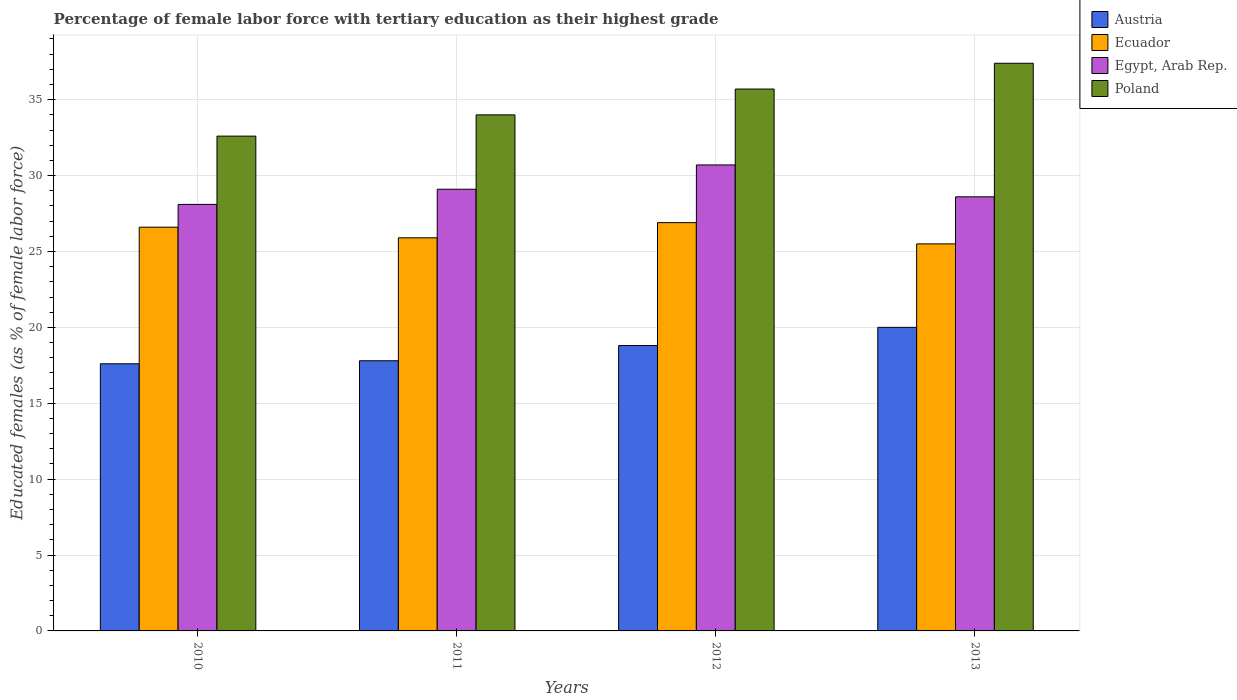How many different coloured bars are there?
Give a very brief answer. 4. Are the number of bars per tick equal to the number of legend labels?
Make the answer very short. Yes. In how many cases, is the number of bars for a given year not equal to the number of legend labels?
Give a very brief answer. 0. What is the percentage of female labor force with tertiary education in Austria in 2013?
Give a very brief answer. 20. Across all years, what is the maximum percentage of female labor force with tertiary education in Egypt, Arab Rep.?
Keep it short and to the point. 30.7. Across all years, what is the minimum percentage of female labor force with tertiary education in Ecuador?
Offer a very short reply. 25.5. In which year was the percentage of female labor force with tertiary education in Poland minimum?
Keep it short and to the point. 2010. What is the total percentage of female labor force with tertiary education in Egypt, Arab Rep. in the graph?
Provide a short and direct response. 116.5. What is the difference between the percentage of female labor force with tertiary education in Austria in 2011 and that in 2012?
Ensure brevity in your answer.  -1. What is the difference between the percentage of female labor force with tertiary education in Austria in 2010 and the percentage of female labor force with tertiary education in Poland in 2012?
Ensure brevity in your answer.  -18.1. What is the average percentage of female labor force with tertiary education in Ecuador per year?
Make the answer very short. 26.22. In the year 2012, what is the difference between the percentage of female labor force with tertiary education in Austria and percentage of female labor force with tertiary education in Ecuador?
Offer a very short reply. -8.1. What is the ratio of the percentage of female labor force with tertiary education in Austria in 2011 to that in 2012?
Offer a terse response. 0.95. What is the difference between the highest and the second highest percentage of female labor force with tertiary education in Poland?
Provide a short and direct response. 1.7. What is the difference between the highest and the lowest percentage of female labor force with tertiary education in Egypt, Arab Rep.?
Offer a terse response. 2.6. Is it the case that in every year, the sum of the percentage of female labor force with tertiary education in Ecuador and percentage of female labor force with tertiary education in Austria is greater than the sum of percentage of female labor force with tertiary education in Egypt, Arab Rep. and percentage of female labor force with tertiary education in Poland?
Keep it short and to the point. No. What does the 3rd bar from the left in 2013 represents?
Provide a short and direct response. Egypt, Arab Rep. What does the 1st bar from the right in 2010 represents?
Ensure brevity in your answer.  Poland. What is the difference between two consecutive major ticks on the Y-axis?
Offer a terse response. 5. Does the graph contain any zero values?
Your answer should be very brief. No. Where does the legend appear in the graph?
Offer a terse response. Top right. How many legend labels are there?
Offer a terse response. 4. How are the legend labels stacked?
Offer a terse response. Vertical. What is the title of the graph?
Give a very brief answer. Percentage of female labor force with tertiary education as their highest grade. What is the label or title of the X-axis?
Your response must be concise. Years. What is the label or title of the Y-axis?
Give a very brief answer. Educated females (as % of female labor force). What is the Educated females (as % of female labor force) in Austria in 2010?
Offer a very short reply. 17.6. What is the Educated females (as % of female labor force) in Ecuador in 2010?
Give a very brief answer. 26.6. What is the Educated females (as % of female labor force) of Egypt, Arab Rep. in 2010?
Make the answer very short. 28.1. What is the Educated females (as % of female labor force) in Poland in 2010?
Offer a very short reply. 32.6. What is the Educated females (as % of female labor force) of Austria in 2011?
Make the answer very short. 17.8. What is the Educated females (as % of female labor force) of Ecuador in 2011?
Offer a very short reply. 25.9. What is the Educated females (as % of female labor force) in Egypt, Arab Rep. in 2011?
Keep it short and to the point. 29.1. What is the Educated females (as % of female labor force) of Poland in 2011?
Offer a very short reply. 34. What is the Educated females (as % of female labor force) of Austria in 2012?
Give a very brief answer. 18.8. What is the Educated females (as % of female labor force) in Ecuador in 2012?
Keep it short and to the point. 26.9. What is the Educated females (as % of female labor force) of Egypt, Arab Rep. in 2012?
Provide a short and direct response. 30.7. What is the Educated females (as % of female labor force) in Poland in 2012?
Ensure brevity in your answer.  35.7. What is the Educated females (as % of female labor force) of Austria in 2013?
Offer a terse response. 20. What is the Educated females (as % of female labor force) in Egypt, Arab Rep. in 2013?
Your response must be concise. 28.6. What is the Educated females (as % of female labor force) of Poland in 2013?
Provide a short and direct response. 37.4. Across all years, what is the maximum Educated females (as % of female labor force) in Ecuador?
Provide a succinct answer. 26.9. Across all years, what is the maximum Educated females (as % of female labor force) of Egypt, Arab Rep.?
Keep it short and to the point. 30.7. Across all years, what is the maximum Educated females (as % of female labor force) of Poland?
Offer a very short reply. 37.4. Across all years, what is the minimum Educated females (as % of female labor force) of Austria?
Your response must be concise. 17.6. Across all years, what is the minimum Educated females (as % of female labor force) of Egypt, Arab Rep.?
Give a very brief answer. 28.1. Across all years, what is the minimum Educated females (as % of female labor force) in Poland?
Make the answer very short. 32.6. What is the total Educated females (as % of female labor force) of Austria in the graph?
Offer a terse response. 74.2. What is the total Educated females (as % of female labor force) in Ecuador in the graph?
Provide a short and direct response. 104.9. What is the total Educated females (as % of female labor force) in Egypt, Arab Rep. in the graph?
Offer a very short reply. 116.5. What is the total Educated females (as % of female labor force) of Poland in the graph?
Your answer should be compact. 139.7. What is the difference between the Educated females (as % of female labor force) in Austria in 2010 and that in 2011?
Your answer should be compact. -0.2. What is the difference between the Educated females (as % of female labor force) of Poland in 2010 and that in 2011?
Keep it short and to the point. -1.4. What is the difference between the Educated females (as % of female labor force) of Austria in 2010 and that in 2012?
Your answer should be compact. -1.2. What is the difference between the Educated females (as % of female labor force) of Poland in 2010 and that in 2012?
Ensure brevity in your answer.  -3.1. What is the difference between the Educated females (as % of female labor force) of Ecuador in 2010 and that in 2013?
Your response must be concise. 1.1. What is the difference between the Educated females (as % of female labor force) of Egypt, Arab Rep. in 2010 and that in 2013?
Offer a terse response. -0.5. What is the difference between the Educated females (as % of female labor force) in Poland in 2010 and that in 2013?
Offer a terse response. -4.8. What is the difference between the Educated females (as % of female labor force) in Austria in 2011 and that in 2012?
Provide a short and direct response. -1. What is the difference between the Educated females (as % of female labor force) in Ecuador in 2011 and that in 2012?
Your answer should be compact. -1. What is the difference between the Educated females (as % of female labor force) in Poland in 2011 and that in 2012?
Your response must be concise. -1.7. What is the difference between the Educated females (as % of female labor force) in Austria in 2012 and that in 2013?
Provide a succinct answer. -1.2. What is the difference between the Educated females (as % of female labor force) of Egypt, Arab Rep. in 2012 and that in 2013?
Give a very brief answer. 2.1. What is the difference between the Educated females (as % of female labor force) in Poland in 2012 and that in 2013?
Give a very brief answer. -1.7. What is the difference between the Educated females (as % of female labor force) of Austria in 2010 and the Educated females (as % of female labor force) of Poland in 2011?
Provide a succinct answer. -16.4. What is the difference between the Educated females (as % of female labor force) in Austria in 2010 and the Educated females (as % of female labor force) in Ecuador in 2012?
Ensure brevity in your answer.  -9.3. What is the difference between the Educated females (as % of female labor force) in Austria in 2010 and the Educated females (as % of female labor force) in Poland in 2012?
Keep it short and to the point. -18.1. What is the difference between the Educated females (as % of female labor force) in Ecuador in 2010 and the Educated females (as % of female labor force) in Poland in 2012?
Offer a terse response. -9.1. What is the difference between the Educated females (as % of female labor force) of Egypt, Arab Rep. in 2010 and the Educated females (as % of female labor force) of Poland in 2012?
Keep it short and to the point. -7.6. What is the difference between the Educated females (as % of female labor force) in Austria in 2010 and the Educated females (as % of female labor force) in Egypt, Arab Rep. in 2013?
Your answer should be compact. -11. What is the difference between the Educated females (as % of female labor force) in Austria in 2010 and the Educated females (as % of female labor force) in Poland in 2013?
Give a very brief answer. -19.8. What is the difference between the Educated females (as % of female labor force) in Ecuador in 2010 and the Educated females (as % of female labor force) in Egypt, Arab Rep. in 2013?
Offer a very short reply. -2. What is the difference between the Educated females (as % of female labor force) in Austria in 2011 and the Educated females (as % of female labor force) in Ecuador in 2012?
Offer a very short reply. -9.1. What is the difference between the Educated females (as % of female labor force) in Austria in 2011 and the Educated females (as % of female labor force) in Egypt, Arab Rep. in 2012?
Give a very brief answer. -12.9. What is the difference between the Educated females (as % of female labor force) of Austria in 2011 and the Educated females (as % of female labor force) of Poland in 2012?
Ensure brevity in your answer.  -17.9. What is the difference between the Educated females (as % of female labor force) in Egypt, Arab Rep. in 2011 and the Educated females (as % of female labor force) in Poland in 2012?
Offer a terse response. -6.6. What is the difference between the Educated females (as % of female labor force) of Austria in 2011 and the Educated females (as % of female labor force) of Ecuador in 2013?
Offer a terse response. -7.7. What is the difference between the Educated females (as % of female labor force) in Austria in 2011 and the Educated females (as % of female labor force) in Egypt, Arab Rep. in 2013?
Ensure brevity in your answer.  -10.8. What is the difference between the Educated females (as % of female labor force) in Austria in 2011 and the Educated females (as % of female labor force) in Poland in 2013?
Provide a short and direct response. -19.6. What is the difference between the Educated females (as % of female labor force) in Egypt, Arab Rep. in 2011 and the Educated females (as % of female labor force) in Poland in 2013?
Offer a terse response. -8.3. What is the difference between the Educated females (as % of female labor force) in Austria in 2012 and the Educated females (as % of female labor force) in Egypt, Arab Rep. in 2013?
Offer a very short reply. -9.8. What is the difference between the Educated females (as % of female labor force) in Austria in 2012 and the Educated females (as % of female labor force) in Poland in 2013?
Your answer should be very brief. -18.6. What is the difference between the Educated females (as % of female labor force) in Ecuador in 2012 and the Educated females (as % of female labor force) in Poland in 2013?
Provide a short and direct response. -10.5. What is the difference between the Educated females (as % of female labor force) in Egypt, Arab Rep. in 2012 and the Educated females (as % of female labor force) in Poland in 2013?
Ensure brevity in your answer.  -6.7. What is the average Educated females (as % of female labor force) of Austria per year?
Provide a short and direct response. 18.55. What is the average Educated females (as % of female labor force) in Ecuador per year?
Make the answer very short. 26.23. What is the average Educated females (as % of female labor force) in Egypt, Arab Rep. per year?
Provide a short and direct response. 29.12. What is the average Educated females (as % of female labor force) in Poland per year?
Your answer should be very brief. 34.92. In the year 2010, what is the difference between the Educated females (as % of female labor force) of Austria and Educated females (as % of female labor force) of Ecuador?
Your response must be concise. -9. In the year 2010, what is the difference between the Educated females (as % of female labor force) in Austria and Educated females (as % of female labor force) in Poland?
Keep it short and to the point. -15. In the year 2010, what is the difference between the Educated females (as % of female labor force) in Ecuador and Educated females (as % of female labor force) in Egypt, Arab Rep.?
Provide a short and direct response. -1.5. In the year 2010, what is the difference between the Educated females (as % of female labor force) of Ecuador and Educated females (as % of female labor force) of Poland?
Make the answer very short. -6. In the year 2011, what is the difference between the Educated females (as % of female labor force) of Austria and Educated females (as % of female labor force) of Egypt, Arab Rep.?
Offer a terse response. -11.3. In the year 2011, what is the difference between the Educated females (as % of female labor force) of Austria and Educated females (as % of female labor force) of Poland?
Provide a succinct answer. -16.2. In the year 2011, what is the difference between the Educated females (as % of female labor force) in Ecuador and Educated females (as % of female labor force) in Poland?
Keep it short and to the point. -8.1. In the year 2012, what is the difference between the Educated females (as % of female labor force) of Austria and Educated females (as % of female labor force) of Ecuador?
Offer a very short reply. -8.1. In the year 2012, what is the difference between the Educated females (as % of female labor force) of Austria and Educated females (as % of female labor force) of Egypt, Arab Rep.?
Offer a terse response. -11.9. In the year 2012, what is the difference between the Educated females (as % of female labor force) in Austria and Educated females (as % of female labor force) in Poland?
Offer a terse response. -16.9. In the year 2012, what is the difference between the Educated females (as % of female labor force) in Ecuador and Educated females (as % of female labor force) in Egypt, Arab Rep.?
Offer a very short reply. -3.8. In the year 2012, what is the difference between the Educated females (as % of female labor force) of Ecuador and Educated females (as % of female labor force) of Poland?
Provide a short and direct response. -8.8. In the year 2012, what is the difference between the Educated females (as % of female labor force) of Egypt, Arab Rep. and Educated females (as % of female labor force) of Poland?
Your response must be concise. -5. In the year 2013, what is the difference between the Educated females (as % of female labor force) in Austria and Educated females (as % of female labor force) in Ecuador?
Provide a short and direct response. -5.5. In the year 2013, what is the difference between the Educated females (as % of female labor force) in Austria and Educated females (as % of female labor force) in Egypt, Arab Rep.?
Give a very brief answer. -8.6. In the year 2013, what is the difference between the Educated females (as % of female labor force) of Austria and Educated females (as % of female labor force) of Poland?
Your response must be concise. -17.4. In the year 2013, what is the difference between the Educated females (as % of female labor force) in Ecuador and Educated females (as % of female labor force) in Poland?
Your response must be concise. -11.9. What is the ratio of the Educated females (as % of female labor force) in Egypt, Arab Rep. in 2010 to that in 2011?
Your response must be concise. 0.97. What is the ratio of the Educated females (as % of female labor force) of Poland in 2010 to that in 2011?
Keep it short and to the point. 0.96. What is the ratio of the Educated females (as % of female labor force) of Austria in 2010 to that in 2012?
Keep it short and to the point. 0.94. What is the ratio of the Educated females (as % of female labor force) in Ecuador in 2010 to that in 2012?
Provide a succinct answer. 0.99. What is the ratio of the Educated females (as % of female labor force) of Egypt, Arab Rep. in 2010 to that in 2012?
Your response must be concise. 0.92. What is the ratio of the Educated females (as % of female labor force) of Poland in 2010 to that in 2012?
Your answer should be compact. 0.91. What is the ratio of the Educated females (as % of female labor force) of Austria in 2010 to that in 2013?
Offer a very short reply. 0.88. What is the ratio of the Educated females (as % of female labor force) in Ecuador in 2010 to that in 2013?
Make the answer very short. 1.04. What is the ratio of the Educated females (as % of female labor force) of Egypt, Arab Rep. in 2010 to that in 2013?
Your response must be concise. 0.98. What is the ratio of the Educated females (as % of female labor force) of Poland in 2010 to that in 2013?
Offer a terse response. 0.87. What is the ratio of the Educated females (as % of female labor force) in Austria in 2011 to that in 2012?
Keep it short and to the point. 0.95. What is the ratio of the Educated females (as % of female labor force) of Ecuador in 2011 to that in 2012?
Offer a very short reply. 0.96. What is the ratio of the Educated females (as % of female labor force) of Egypt, Arab Rep. in 2011 to that in 2012?
Provide a succinct answer. 0.95. What is the ratio of the Educated females (as % of female labor force) of Poland in 2011 to that in 2012?
Give a very brief answer. 0.95. What is the ratio of the Educated females (as % of female labor force) of Austria in 2011 to that in 2013?
Provide a short and direct response. 0.89. What is the ratio of the Educated females (as % of female labor force) of Ecuador in 2011 to that in 2013?
Ensure brevity in your answer.  1.02. What is the ratio of the Educated females (as % of female labor force) in Egypt, Arab Rep. in 2011 to that in 2013?
Ensure brevity in your answer.  1.02. What is the ratio of the Educated females (as % of female labor force) in Austria in 2012 to that in 2013?
Provide a succinct answer. 0.94. What is the ratio of the Educated females (as % of female labor force) of Ecuador in 2012 to that in 2013?
Your answer should be compact. 1.05. What is the ratio of the Educated females (as % of female labor force) of Egypt, Arab Rep. in 2012 to that in 2013?
Provide a short and direct response. 1.07. What is the ratio of the Educated females (as % of female labor force) in Poland in 2012 to that in 2013?
Offer a very short reply. 0.95. What is the difference between the highest and the second highest Educated females (as % of female labor force) in Austria?
Offer a very short reply. 1.2. What is the difference between the highest and the second highest Educated females (as % of female labor force) in Ecuador?
Offer a very short reply. 0.3. What is the difference between the highest and the second highest Educated females (as % of female labor force) of Egypt, Arab Rep.?
Make the answer very short. 1.6. What is the difference between the highest and the lowest Educated females (as % of female labor force) in Egypt, Arab Rep.?
Ensure brevity in your answer.  2.6. What is the difference between the highest and the lowest Educated females (as % of female labor force) in Poland?
Provide a short and direct response. 4.8. 